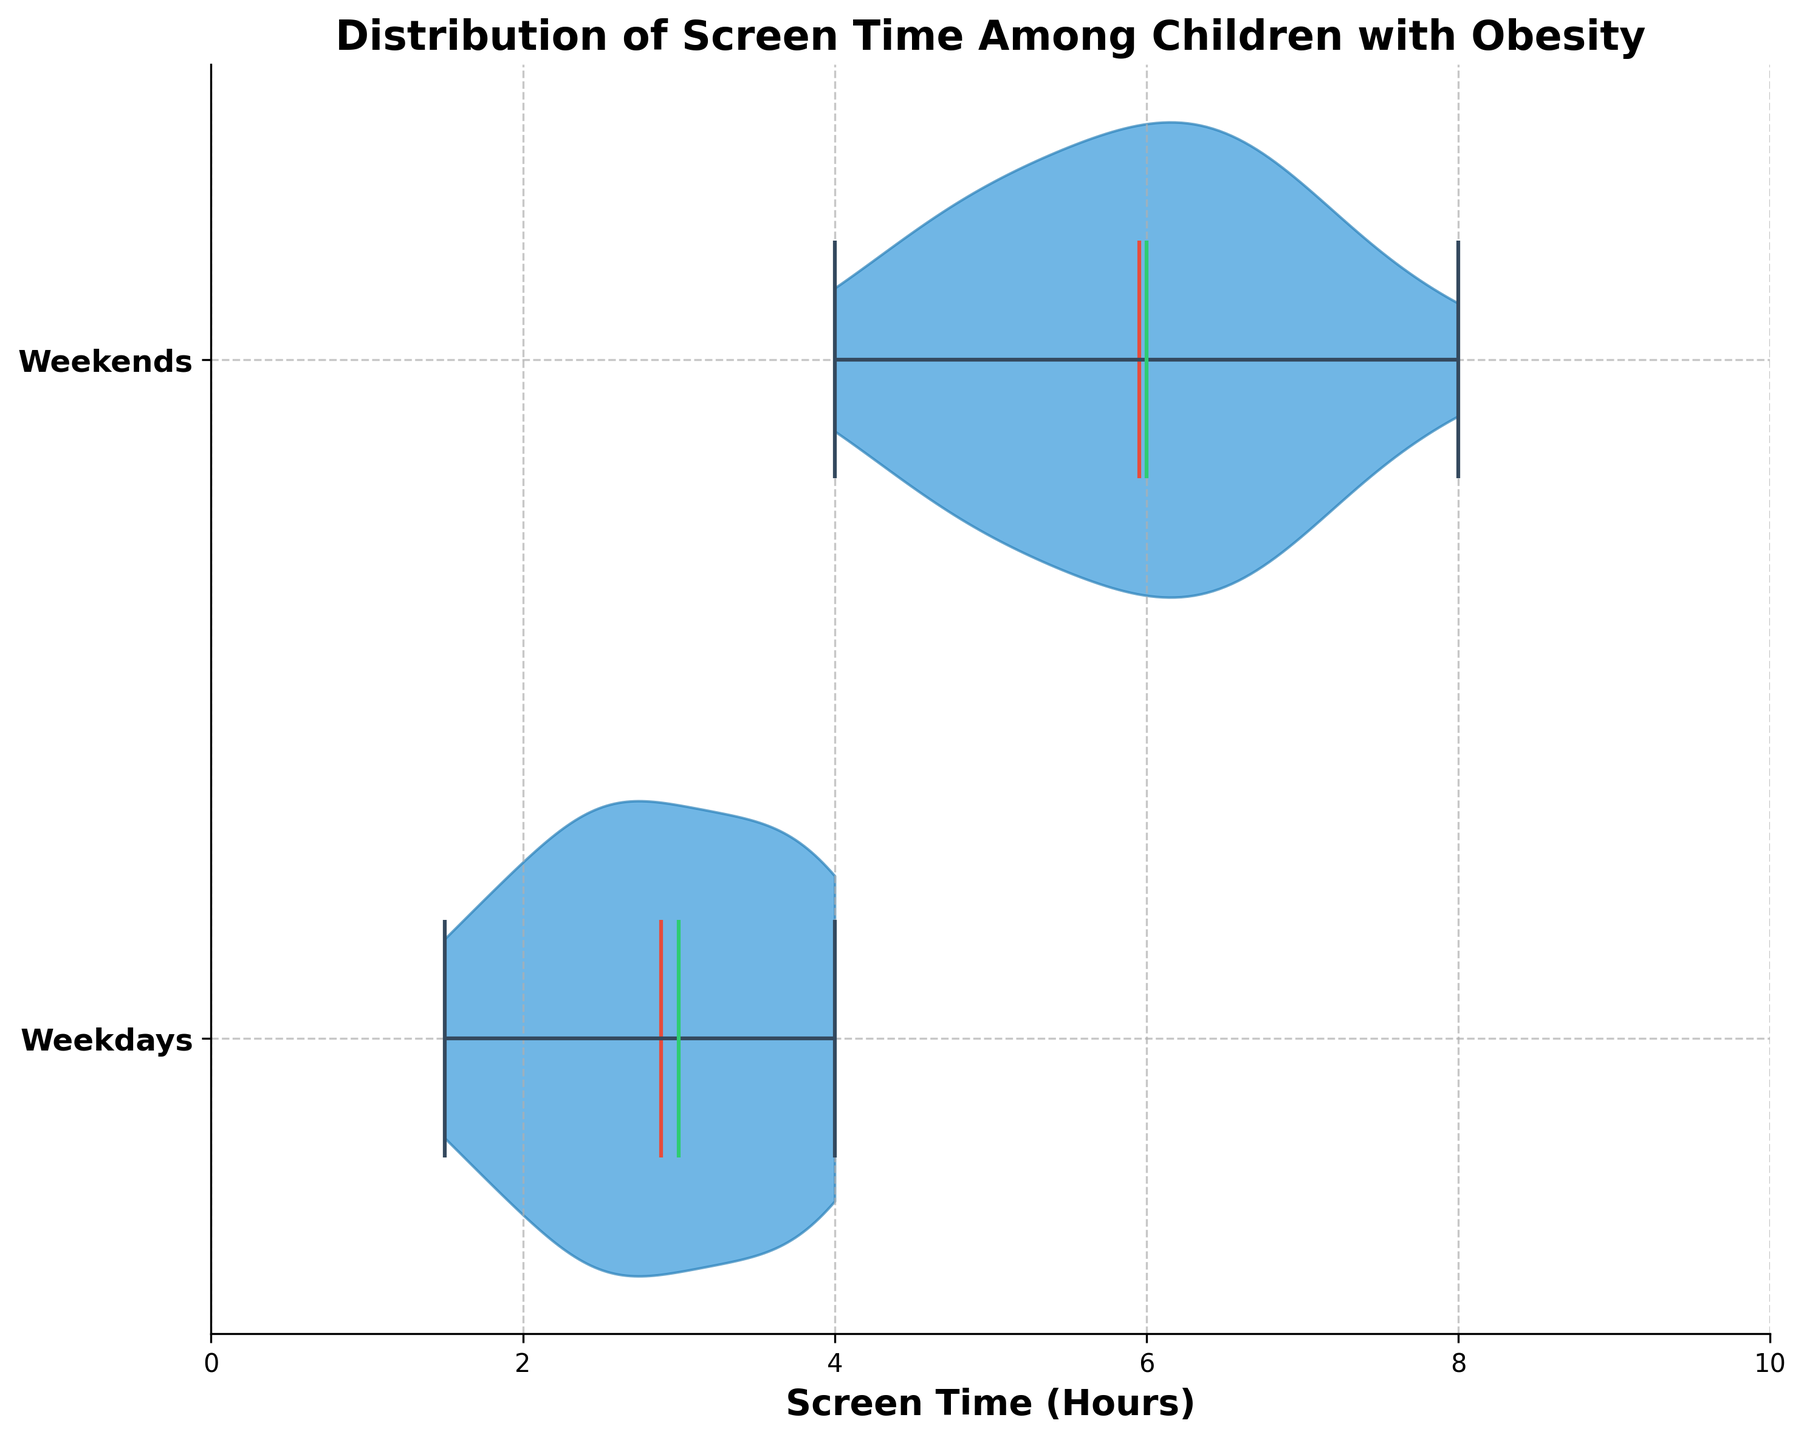How many groups are presented in the chart? The chart shows two distributions, labeled as 'Weekdays' and 'Weekends', each representing a different group for screen time hours.
Answer: 2 What is the title of the chart? The title is prominently displayed at the top of the chart.
Answer: Distribution of Screen Time Among Children with Obesity What is the color used for the mean in the chart? The mean of each distribution is highlighted in a distinct red color.
Answer: Red Which group has a higher median screen time? The median lines are indicated by a different color (green), making it easy to see and compare their positions along the x-axis. The median for weekends is further to the right.
Answer: Weekends Compare the spread of screen time between weekdays and weekends. The 'spread' refers to the width of the violin plot, which indicates the distribution density. The weekends’ distribution is wider, indicating a greater spread compared to weekdays.
Answer: Weekends What is the maximum screen time observed on weekends? The maximum value is represented by the top edge of the outermost horizontal line in the weekend group.
Answer: 8.0 hours Which group shows a more centralized distribution around the mean? The centralization around the mean can be noted by observing the vioplots' symmetry and density near the mean line. Weekdays show a more centralized distribution.
Answer: Weekdays What is the range of screen time hours on weekends? To find the range, look at the span from the minimum to the maximum horizontal line in the weekends distribution. Range = 8.0 (max) - 4.0 (min)
Answer: 4.0 Are there any overlaps in screen time distributions between weekdays and weekends? Overlaps can be identified by checking if there is any horizontal alignment in the spread of the violins. They both overlap between 1.5 to 4.0 hours.
Answer: Yes Which group has a higher mean screen time? The mean lines (red) help to compare directly between the two groups. The mean line on weekends is further to the right.
Answer: Weekends 